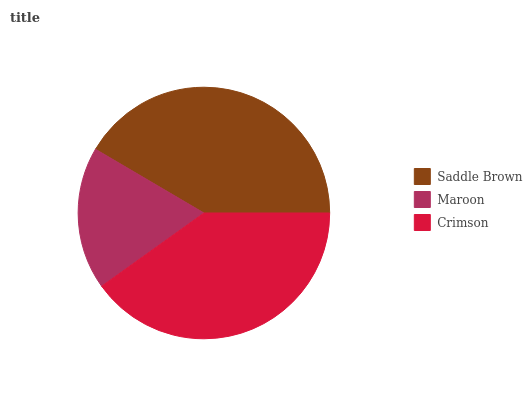Is Maroon the minimum?
Answer yes or no. Yes. Is Saddle Brown the maximum?
Answer yes or no. Yes. Is Crimson the minimum?
Answer yes or no. No. Is Crimson the maximum?
Answer yes or no. No. Is Crimson greater than Maroon?
Answer yes or no. Yes. Is Maroon less than Crimson?
Answer yes or no. Yes. Is Maroon greater than Crimson?
Answer yes or no. No. Is Crimson less than Maroon?
Answer yes or no. No. Is Crimson the high median?
Answer yes or no. Yes. Is Crimson the low median?
Answer yes or no. Yes. Is Maroon the high median?
Answer yes or no. No. Is Maroon the low median?
Answer yes or no. No. 